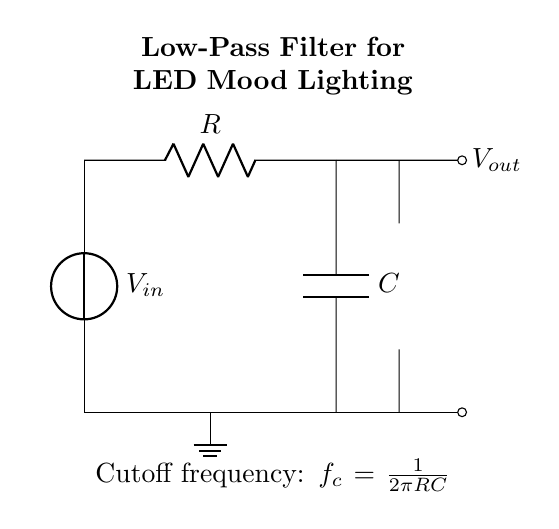What components are in the circuit? The circuit includes a voltage source, resistor, capacitor, LED, and ground. Each component serves a specific function in filtering and lighting.
Answer: voltage source, resistor, capacitor, LED, ground What is the output of the circuit? The output is connected to the LED, which indicates that the filtered voltage will power the LED for mood lighting. The LED lights up based on the output voltage.
Answer: LED What is the function of the capacitor? The capacitor in this low-pass filter circuit works to smooth out voltage fluctuations, allowing only low-frequency signals to pass while filtering out high-frequency noise.
Answer: Filter noise What is the cutoff frequency formula? The cutoff frequency of a low-pass filter is determined using the formula f_c = 1 / (2πRC), indicating the frequency at which the output signal begins to decrease.
Answer: 1 / (2πRC) How does increasing the resistance affect the cutoff frequency? Increasing the resistance (R) in the cutoff frequency formula will result in a lower cutoff frequency (f_c). This means that the filter will allow even lower frequencies to pass while attenuating the higher frequencies.
Answer: Lower cutoff frequency What happens if the capacitor value is decreased? Decreasing the capacitance (C) will increase the cutoff frequency (f_c), allowing higher frequencies to pass through the filter while allowing less attenuation on higher frequencies.
Answer: Higher cutoff frequency How is the ground connected in this circuit? The ground serves as the reference point for the circuit, connecting one terminal of the voltage source and the bottom of the capacitor to establish a common return path for the current.
Answer: Ground 